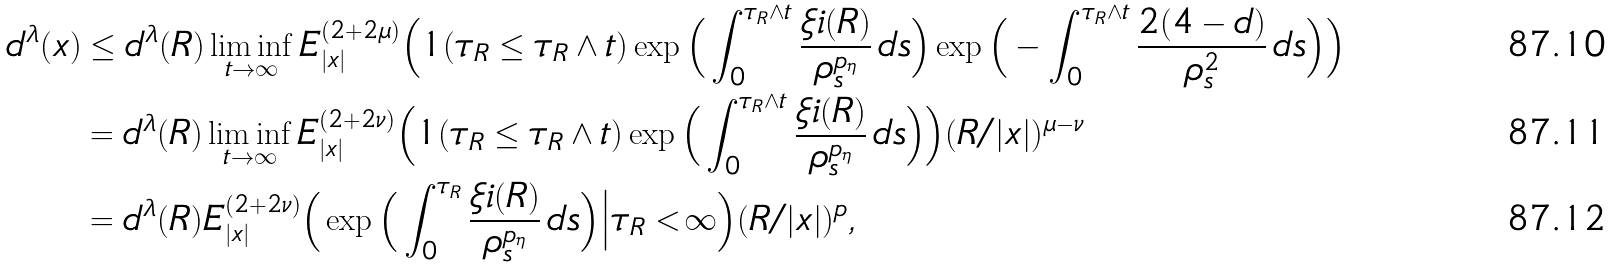Convert formula to latex. <formula><loc_0><loc_0><loc_500><loc_500>d ^ { \lambda } ( x ) & \leq d ^ { \lambda } ( R ) \liminf _ { t \to \infty } E _ { | x | } ^ { ( 2 + 2 \mu ) } \Big ( 1 ( \tau _ { R } \leq \tau _ { R } \wedge t ) \exp \Big ( \int _ { 0 } ^ { \tau _ { R } \wedge t } \frac { \xi i ( R ) } { \rho _ { s } ^ { p _ { \eta } } } \, d s \Big ) \exp \Big ( - \int _ { 0 } ^ { \tau _ { R } \wedge t } \frac { 2 ( 4 - d ) } { \rho _ { s } ^ { 2 } } \, d s \Big ) \Big ) \\ & = d ^ { \lambda } ( R ) \liminf _ { t \to \infty } E _ { | x | } ^ { ( 2 + 2 \nu ) } \Big ( 1 ( \tau _ { R } \leq \tau _ { R } \wedge t ) \exp \Big ( \int _ { 0 } ^ { \tau _ { R } \wedge t } \frac { \xi i ( R ) } { \rho _ { s } ^ { p _ { \eta } } } \, d s \Big ) \Big ) ( R / | x | ) ^ { \mu - \nu } \\ & = d ^ { \lambda } ( R ) E _ { | x | } ^ { ( 2 + 2 \nu ) } \Big ( \exp \Big ( \int _ { 0 } ^ { \tau _ { R } } \frac { \xi i ( R ) } { \rho _ { s } ^ { p _ { \eta } } } \, d s \Big ) \Big | \tau _ { R } < \infty \Big ) ( R / | x | ) ^ { p } ,</formula> 